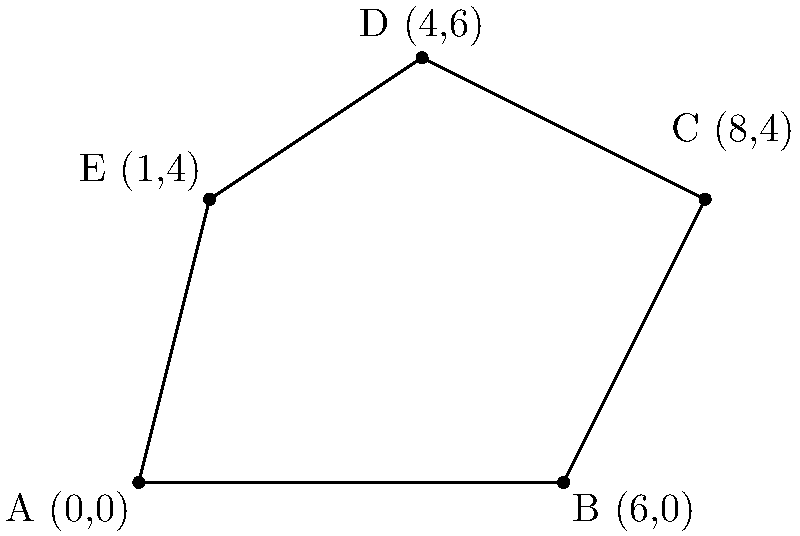Given the radar detection points A(0,0), B(6,0), C(8,4), D(4,6), and E(1,4) on a coordinate grid, calculate the area of the polygon formed by these points. Round your answer to the nearest whole number. To calculate the area of this irregular polygon, we can use the Shoelace formula (also known as the surveyor's formula). The steps are as follows:

1) The Shoelace formula for a polygon with vertices $(x_1, y_1), (x_2, y_2), ..., (x_n, y_n)$ is:

   Area = $\frac{1}{2}|(x_1y_2 + x_2y_3 + ... + x_ny_1) - (y_1x_2 + y_2x_3 + ... + y_nx_1)|$

2) Let's arrange our points in order: A(0,0), B(6,0), C(8,4), D(4,6), E(1,4)

3) Now, let's apply the formula:

   $\frac{1}{2}|[(0 \cdot 0) + (6 \cdot 4) + (8 \cdot 6) + (4 \cdot 4) + (1 \cdot 0)] - [(0 \cdot 6) + (0 \cdot 8) + (4 \cdot 4) + (6 \cdot 1) + (4 \cdot 0)]|$

4) Simplify:
   $\frac{1}{2}|[0 + 24 + 48 + 16 + 0] - [0 + 0 + 16 + 6 + 0]|$

5) Calculate:
   $\frac{1}{2}|88 - 22| = \frac{1}{2} \cdot 66 = 33$

Therefore, the area of the polygon is 33 square units.
Answer: 33 square units 